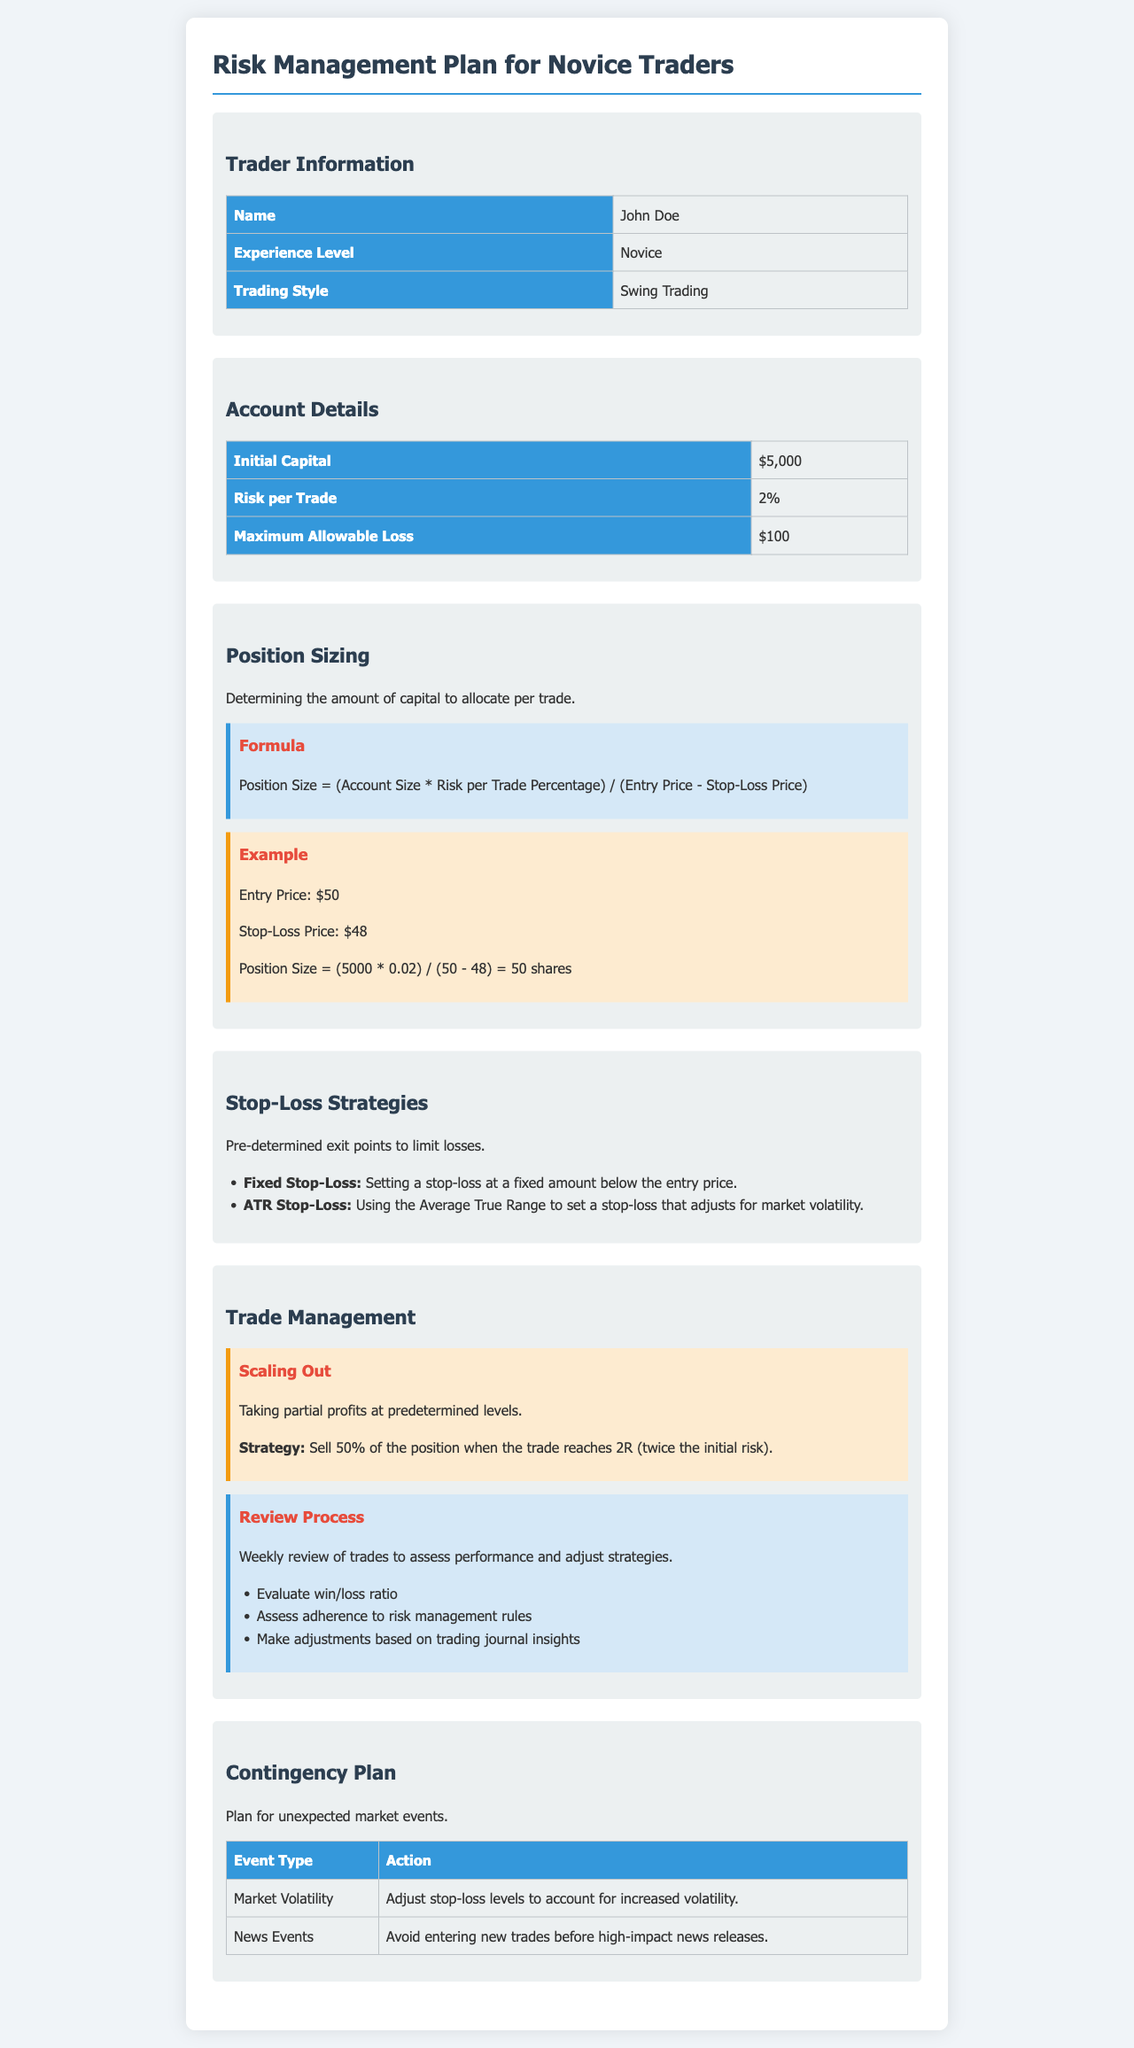What is the trader's name? The trader's name is listed in the Trader Information section.
Answer: John Doe What is the initial capital? The initial capital is mentioned in the Account Details section.
Answer: $5,000 What is the risk per trade? The risk per trade is detailed in the Account Details section.
Answer: 2% What is the maximum allowable loss? The maximum allowable loss is specified in the Account Details section.
Answer: $100 What is the position size formula? The position size formula is provided under the Position Sizing section.
Answer: Position Size = (Account Size * Risk per Trade Percentage) / (Entry Price - Stop-Loss Price) How many shares can be purchased if the entry price is $50 and the stop-loss price is $48? The number of shares is calculated in the example under Position Sizing using the given entry and stop-loss prices.
Answer: 50 shares What type of stop-loss is described as being set at a fixed amount? A specific type of stop-loss is indicated in the Stop-Loss Strategies section.
Answer: Fixed Stop-Loss What is the action taken during market volatility? The action during market volatility is outlined in the Contingency Plan section.
Answer: Adjust stop-loss levels What strategy involves taking partial profits? The strategy for taking partial profits is mentioned in the Trade Management section.
Answer: Scaling Out 